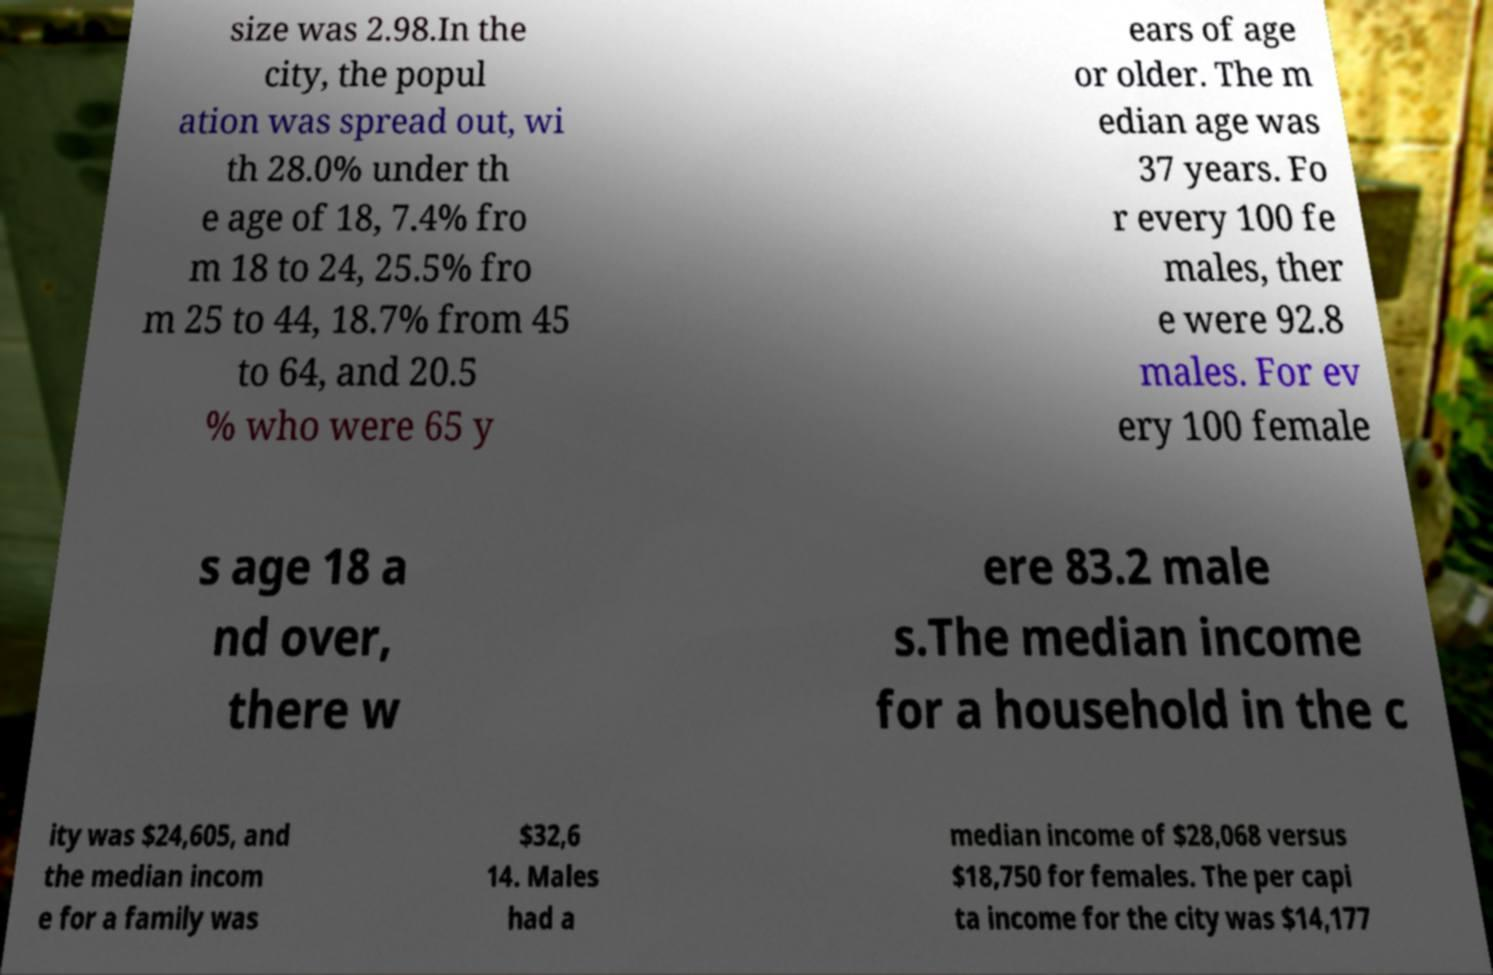What messages or text are displayed in this image? I need them in a readable, typed format. size was 2.98.In the city, the popul ation was spread out, wi th 28.0% under th e age of 18, 7.4% fro m 18 to 24, 25.5% fro m 25 to 44, 18.7% from 45 to 64, and 20.5 % who were 65 y ears of age or older. The m edian age was 37 years. Fo r every 100 fe males, ther e were 92.8 males. For ev ery 100 female s age 18 a nd over, there w ere 83.2 male s.The median income for a household in the c ity was $24,605, and the median incom e for a family was $32,6 14. Males had a median income of $28,068 versus $18,750 for females. The per capi ta income for the city was $14,177 